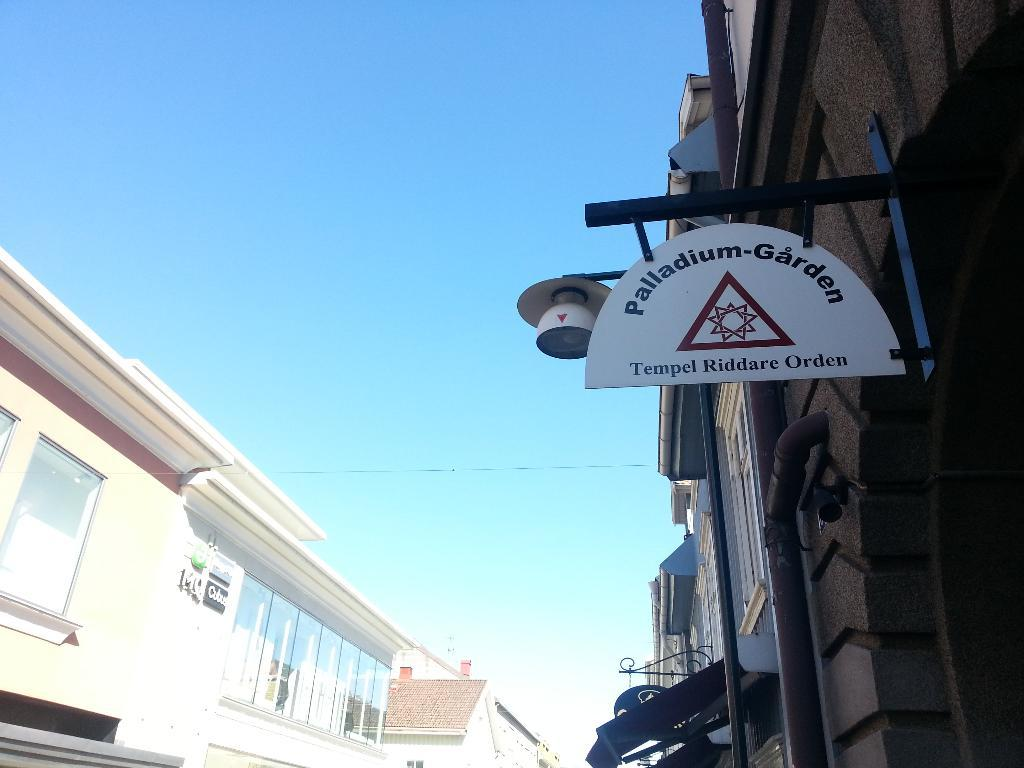What type of signage is present in the image? There are name boards in the image. What type of structures can be seen in the image? There are buildings with windows in the image. What else is visible in the image besides the name boards and buildings? There are objects visible in the image. What can be seen in the background of the image? The sky is visible in the background of the image. Can you see a carriage being pulled by horses in the image? There is no carriage or horses present in the image. Is there a ship visible in the background of the image? There is no ship visible in the image; only the sky is visible in the background. 